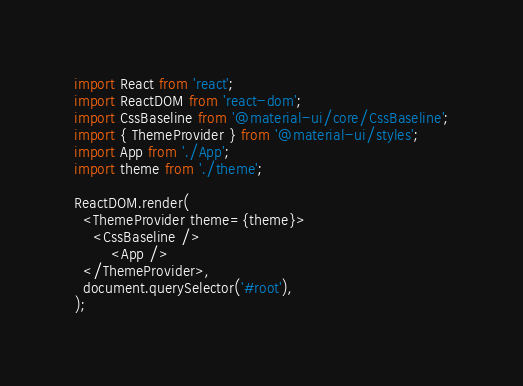<code> <loc_0><loc_0><loc_500><loc_500><_JavaScript_>import React from 'react';
import ReactDOM from 'react-dom';
import CssBaseline from '@material-ui/core/CssBaseline';
import { ThemeProvider } from '@material-ui/styles';
import App from './App';
import theme from './theme';

ReactDOM.render(
  <ThemeProvider theme={theme}>
    <CssBaseline />
        <App />
  </ThemeProvider>,
  document.querySelector('#root'),
);
</code> 